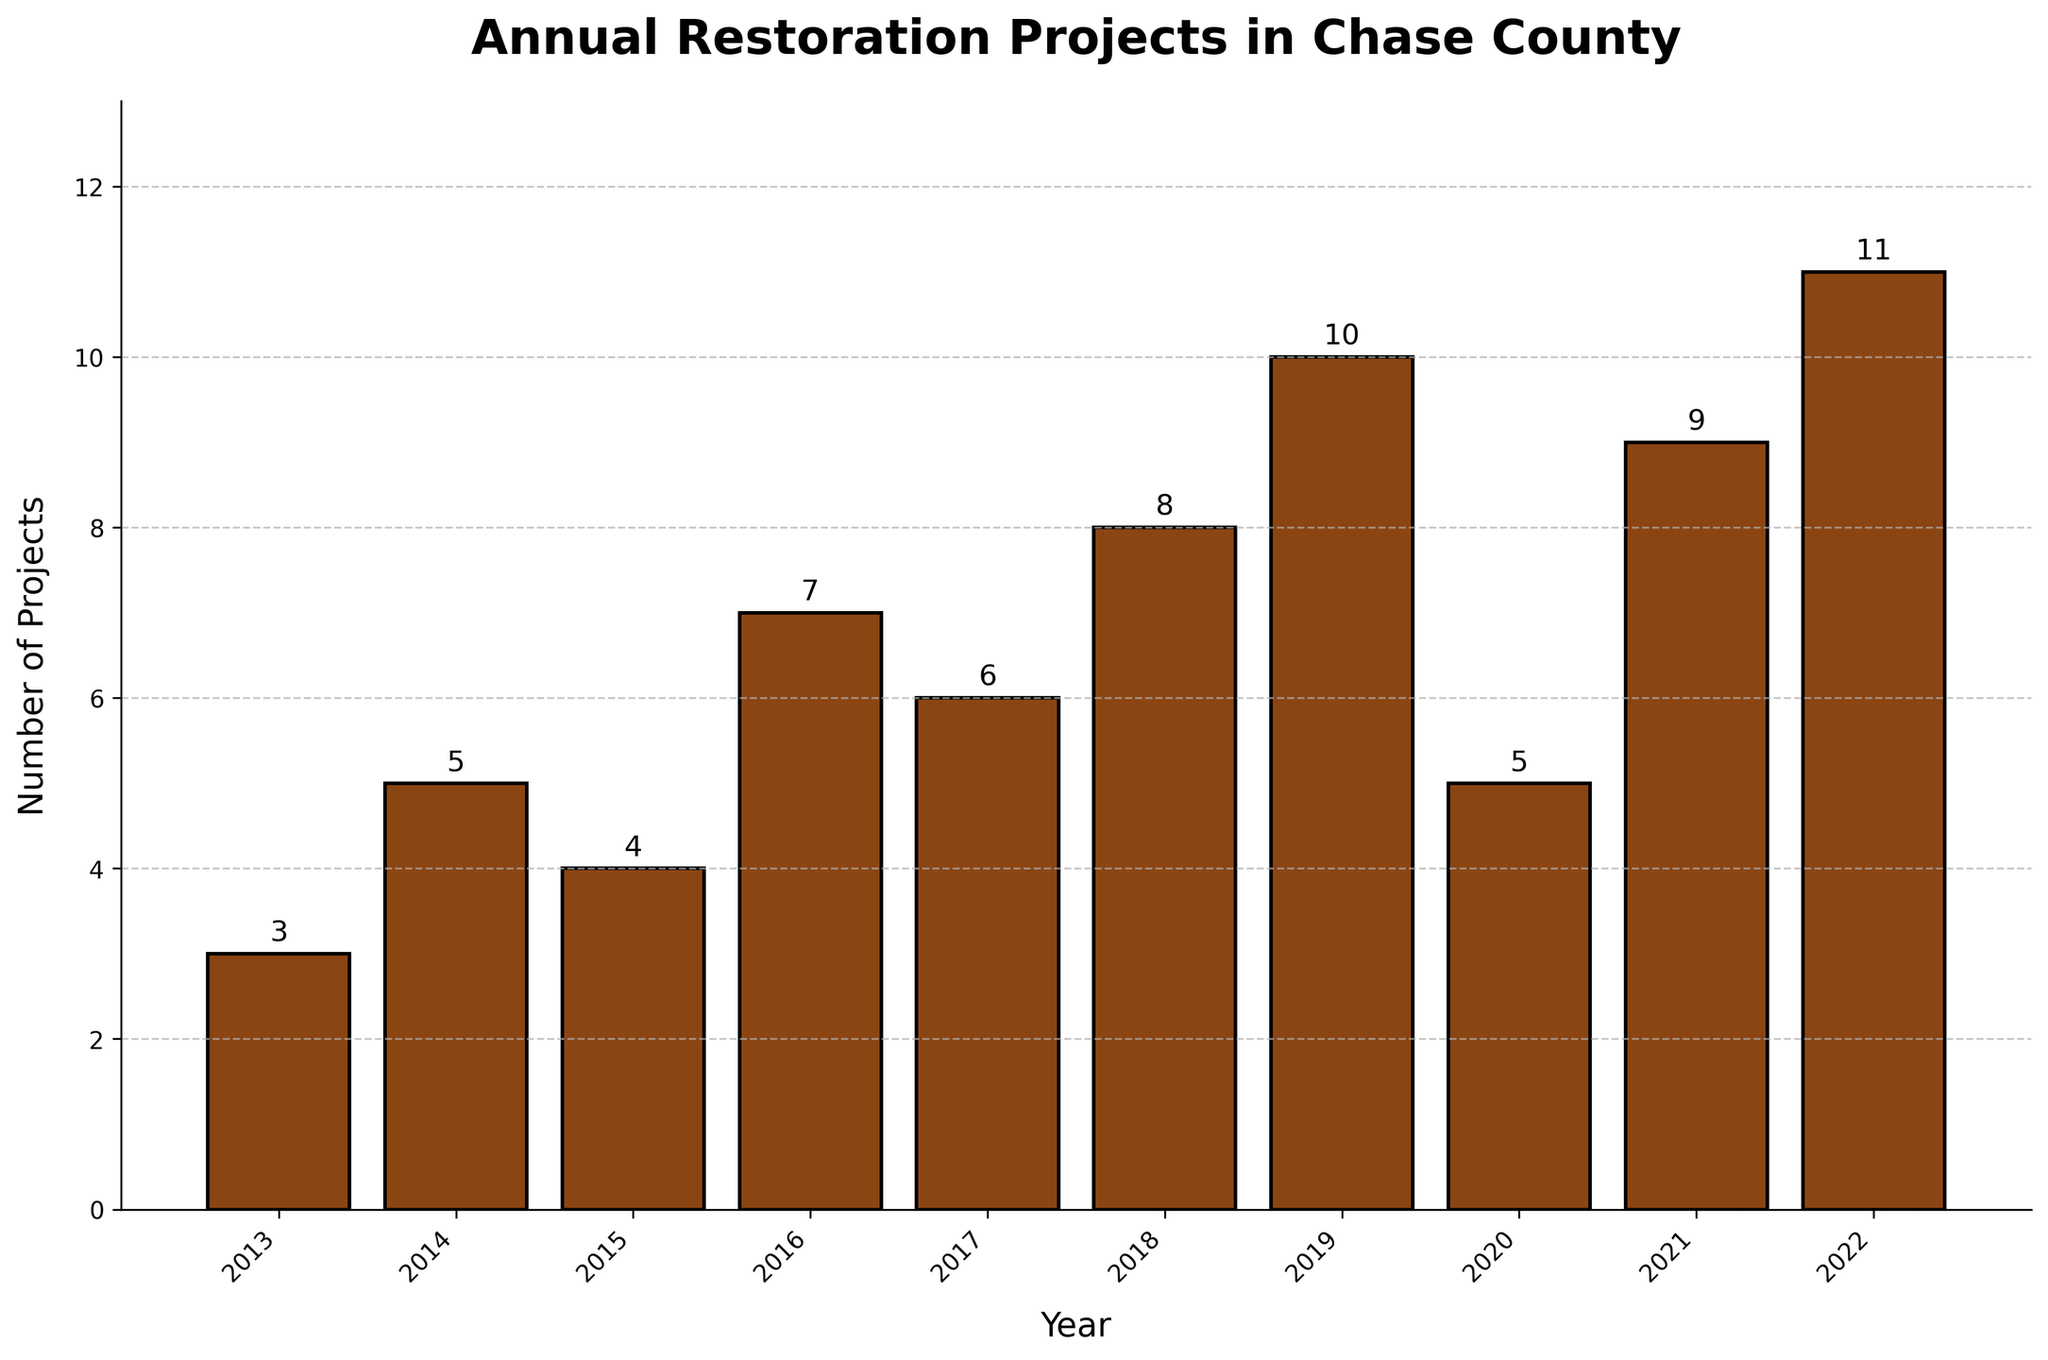What is the total number of restoration projects completed in the years 2019 and 2020? Sum the values for the years 2019 and 2020: 10 (2019) + 5 (2020) = 15
Answer: 15 How many more projects were completed in 2022 than in 2014? Subtract the number of projects in 2014 from the number in 2022: 11 (2022) - 5 (2014) = 6
Answer: 6 Which year had the highest number of restoration projects completed? Identify the year with the tallest bar, which represents the highest count, in this case, 2022 with 11 projects
Answer: 2022 What is the average number of restoration projects completed over the decade? Sum the total number of projects completed over all years and divide by the number of years. (3+5+4+7+6+8+10+5+9+11) = 68, and divide by 10. 68 / 10 = 6.8
Answer: 6.8 Did the number of restoration projects completed in 2016 increase or decrease compared to 2015? Compare the heights of the bars for the years 2015 and 2016. The number increased from 4 (2015) to 7 (2016).
Answer: Increase What is the least number of restoration projects completed in a single year? Identify the year with the shortest bar, which represents the lowest count, in this case, 2013 with 3 projects.
Answer: 3 Was there a consistent increase in the number of projects from 2013 to 2017? Analyze the trend for the years 2013 to 2017. The numbers are 3, 5, 4, 7, 6. The trend is not consistently increasing as 2015 had fewer projects than 2014.
Answer: No By how much did the number of projects decrease from 2019 to 2020? Subtract the number of projects in 2020 from the number in 2019: 10 (2019) - 5 (2020) = 5
Answer: 5 How many years had 8 or more restoration projects completed? Count the number of bars with a height representing 8 or more projects. The years are 2018 (8), 2019 (10), 2021 (9), and 2022 (11), so there are 4 years.
Answer: 4 